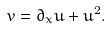Convert formula to latex. <formula><loc_0><loc_0><loc_500><loc_500>v = \partial _ { x } u + u ^ { 2 } .</formula> 